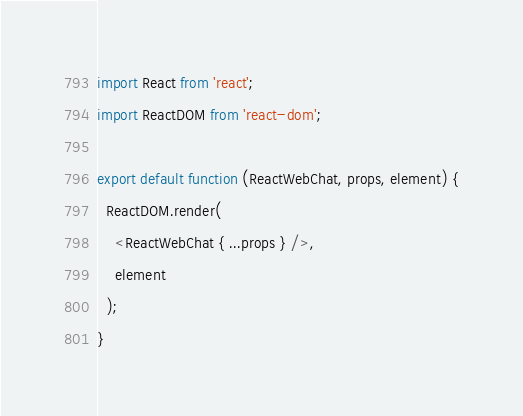Convert code to text. <code><loc_0><loc_0><loc_500><loc_500><_JavaScript_>import React from 'react';
import ReactDOM from 'react-dom';

export default function (ReactWebChat, props, element) {
  ReactDOM.render(
    <ReactWebChat { ...props } />,
    element
  );
}
</code> 